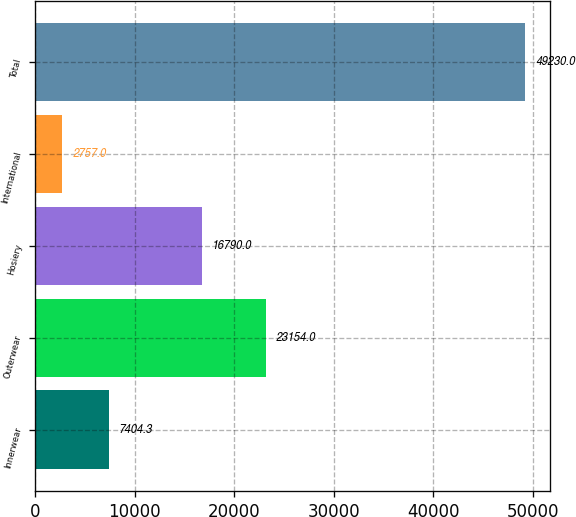<chart> <loc_0><loc_0><loc_500><loc_500><bar_chart><fcel>Innerwear<fcel>Outerwear<fcel>Hosiery<fcel>International<fcel>Total<nl><fcel>7404.3<fcel>23154<fcel>16790<fcel>2757<fcel>49230<nl></chart> 